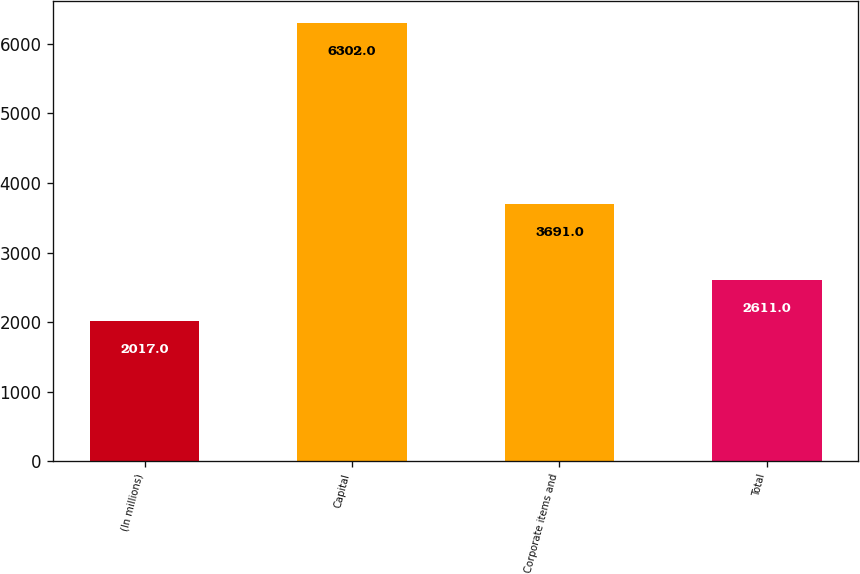<chart> <loc_0><loc_0><loc_500><loc_500><bar_chart><fcel>(In millions)<fcel>Capital<fcel>Corporate items and<fcel>Total<nl><fcel>2017<fcel>6302<fcel>3691<fcel>2611<nl></chart> 